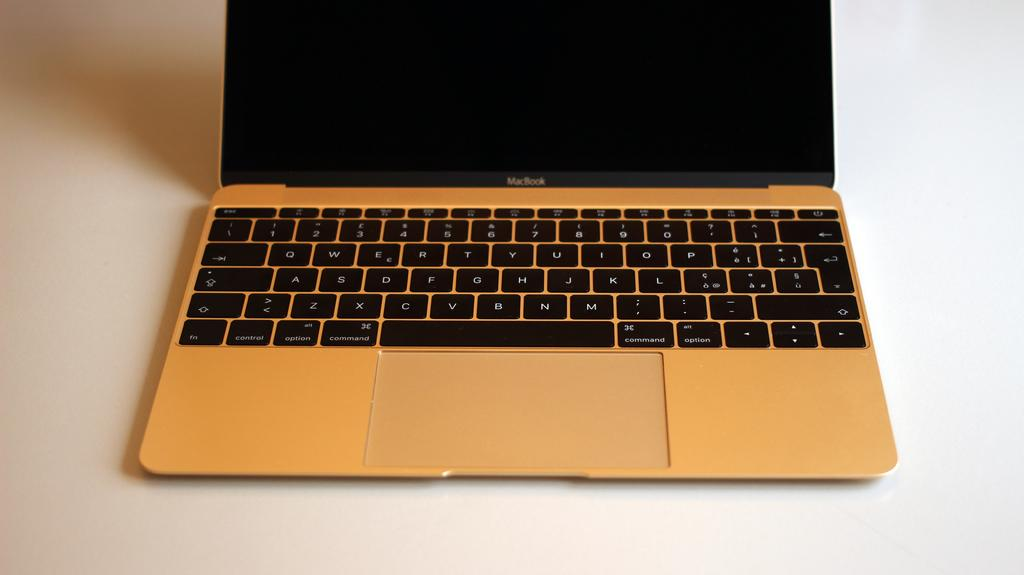<image>
Describe the image concisely. A black and silver laptop with Macbook written on it. 